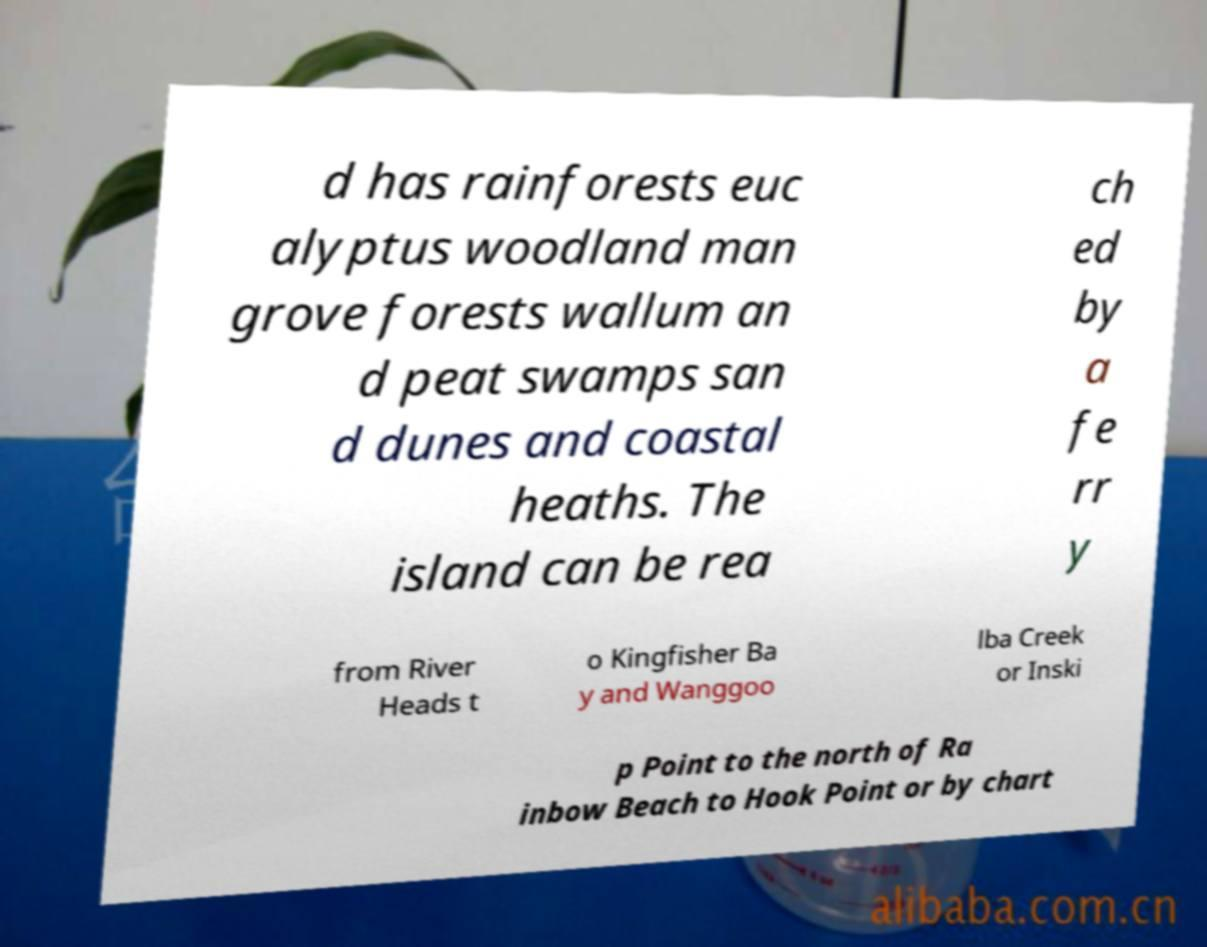What messages or text are displayed in this image? I need them in a readable, typed format. d has rainforests euc alyptus woodland man grove forests wallum an d peat swamps san d dunes and coastal heaths. The island can be rea ch ed by a fe rr y from River Heads t o Kingfisher Ba y and Wanggoo lba Creek or Inski p Point to the north of Ra inbow Beach to Hook Point or by chart 